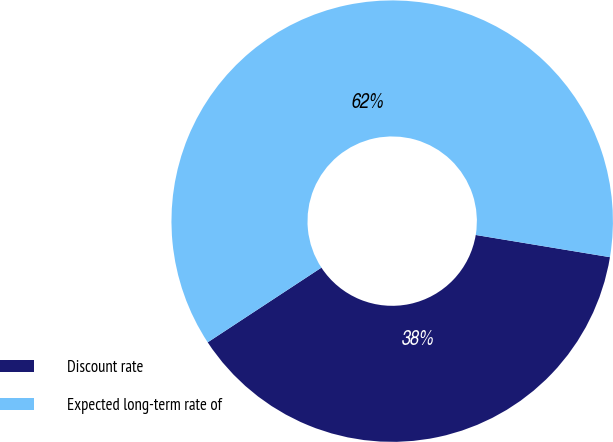Convert chart. <chart><loc_0><loc_0><loc_500><loc_500><pie_chart><fcel>Discount rate<fcel>Expected long-term rate of<nl><fcel>38.14%<fcel>61.86%<nl></chart> 